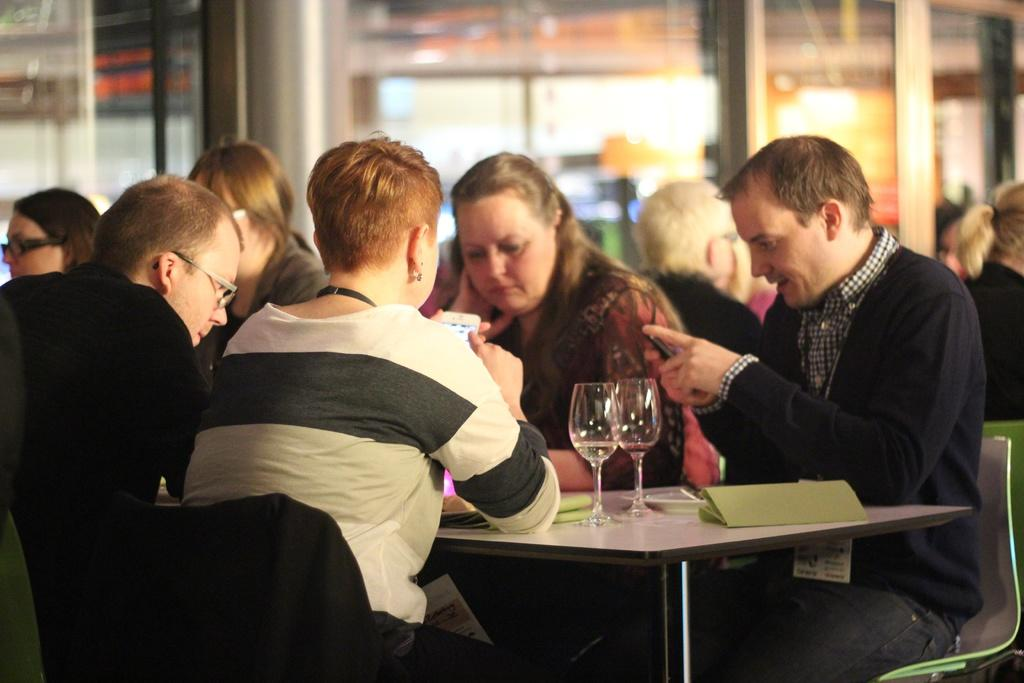How many people are in the image? There are five members in the image. What are the members doing in the image? The members are sitting around a table. What are the members sitting on? The members are seated in chairs. What can be seen on the chairs? Glasses are present on the chairs. What is the gender composition of the group? There are both men and women in the group. Are there any glasses visible in the background of the image? Yes, there are glasses visible in the background of the image. How many chairs are needed for the team to fall off the cliff in the image? There is no cliff or team present in the image, and therefore no such event can be observed. 